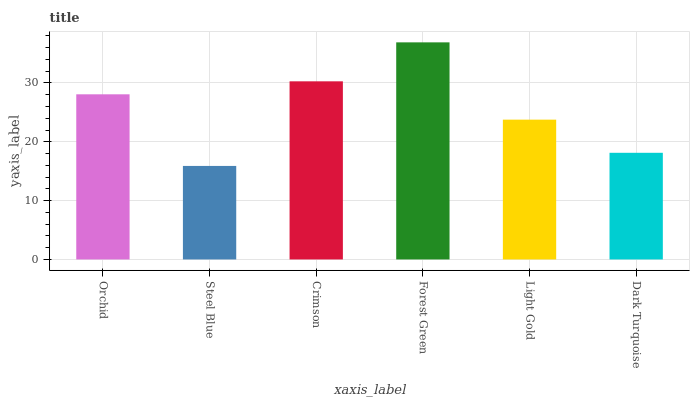Is Steel Blue the minimum?
Answer yes or no. Yes. Is Forest Green the maximum?
Answer yes or no. Yes. Is Crimson the minimum?
Answer yes or no. No. Is Crimson the maximum?
Answer yes or no. No. Is Crimson greater than Steel Blue?
Answer yes or no. Yes. Is Steel Blue less than Crimson?
Answer yes or no. Yes. Is Steel Blue greater than Crimson?
Answer yes or no. No. Is Crimson less than Steel Blue?
Answer yes or no. No. Is Orchid the high median?
Answer yes or no. Yes. Is Light Gold the low median?
Answer yes or no. Yes. Is Dark Turquoise the high median?
Answer yes or no. No. Is Steel Blue the low median?
Answer yes or no. No. 